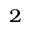Convert formula to latex. <formula><loc_0><loc_0><loc_500><loc_500>_ { 2 }</formula> 